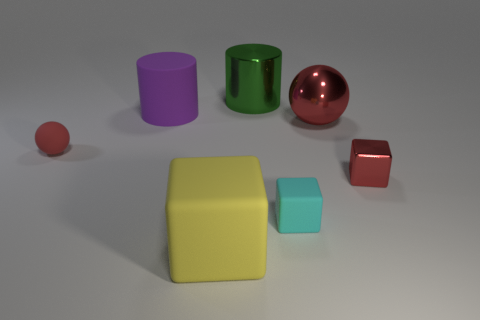There is a small shiny thing that is the same color as the big metallic ball; what shape is it?
Offer a terse response. Cube. There is a yellow object; is it the same size as the rubber block right of the green cylinder?
Give a very brief answer. No. How many brown objects are matte spheres or tiny matte things?
Your answer should be very brief. 0. What number of tiny cyan rubber things are there?
Offer a very short reply. 1. There is a matte thing to the left of the big rubber cylinder; how big is it?
Give a very brief answer. Small. Do the purple cylinder and the yellow rubber object have the same size?
Your response must be concise. Yes. How many objects are red metal spheres or red balls that are left of the green shiny object?
Ensure brevity in your answer.  2. What material is the small cyan thing?
Ensure brevity in your answer.  Rubber. Are there any other things that have the same color as the tiny metal thing?
Offer a very short reply. Yes. Do the tiny red metal thing and the cyan matte object have the same shape?
Your answer should be very brief. Yes. 